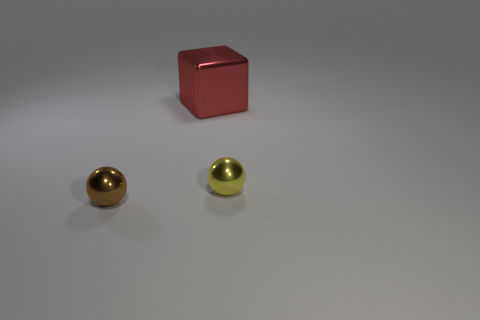How many shiny objects are either blue cubes or brown things?
Give a very brief answer. 1. Is the number of large red objects behind the red object greater than the number of tiny shiny cylinders?
Your answer should be compact. No. What number of other things are there of the same material as the small yellow object
Your answer should be compact. 2. How many small objects are red cubes or metal objects?
Offer a very short reply. 2. Do the large red thing and the yellow sphere have the same material?
Provide a succinct answer. Yes. What number of big things are behind the tiny metal ball in front of the yellow metal sphere?
Your answer should be very brief. 1. Is there another shiny object of the same shape as the small yellow shiny thing?
Keep it short and to the point. Yes. There is a small brown metal thing in front of the big object; is it the same shape as the small shiny object right of the brown thing?
Your response must be concise. Yes. What is the shape of the object that is both right of the brown metal ball and left of the yellow metal object?
Ensure brevity in your answer.  Cube. Are there any cyan shiny cylinders of the same size as the cube?
Offer a terse response. No. 